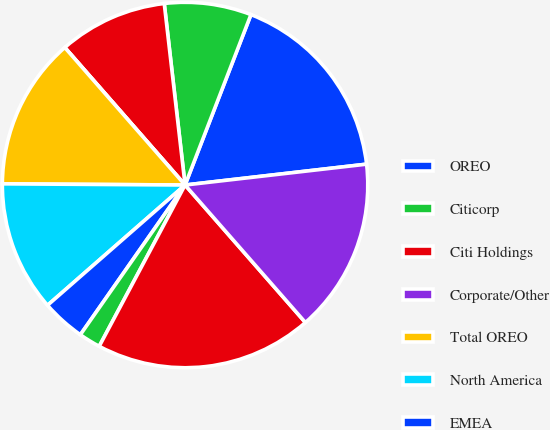<chart> <loc_0><loc_0><loc_500><loc_500><pie_chart><fcel>OREO<fcel>Citicorp<fcel>Citi Holdings<fcel>Corporate/Other<fcel>Total OREO<fcel>North America<fcel>EMEA<fcel>Latin America<fcel>Non-accrual assets-Total<fcel>Corporate non-accrual loans<nl><fcel>17.31%<fcel>7.69%<fcel>9.62%<fcel>0.0%<fcel>13.46%<fcel>11.54%<fcel>3.85%<fcel>1.93%<fcel>19.23%<fcel>15.38%<nl></chart> 